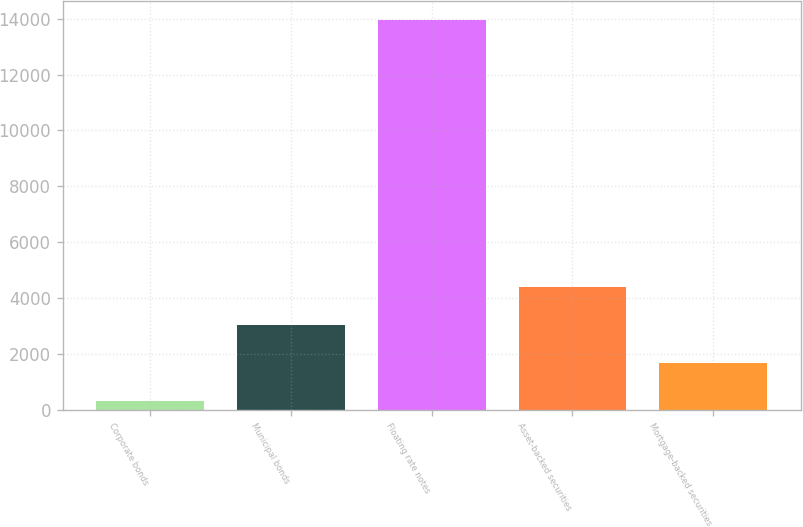Convert chart. <chart><loc_0><loc_0><loc_500><loc_500><bar_chart><fcel>Corporate bonds<fcel>Municipal bonds<fcel>Floating rate notes<fcel>Asset-backed securities<fcel>Mortgage-backed securities<nl><fcel>301<fcel>3030.8<fcel>13950<fcel>4395.7<fcel>1665.9<nl></chart> 